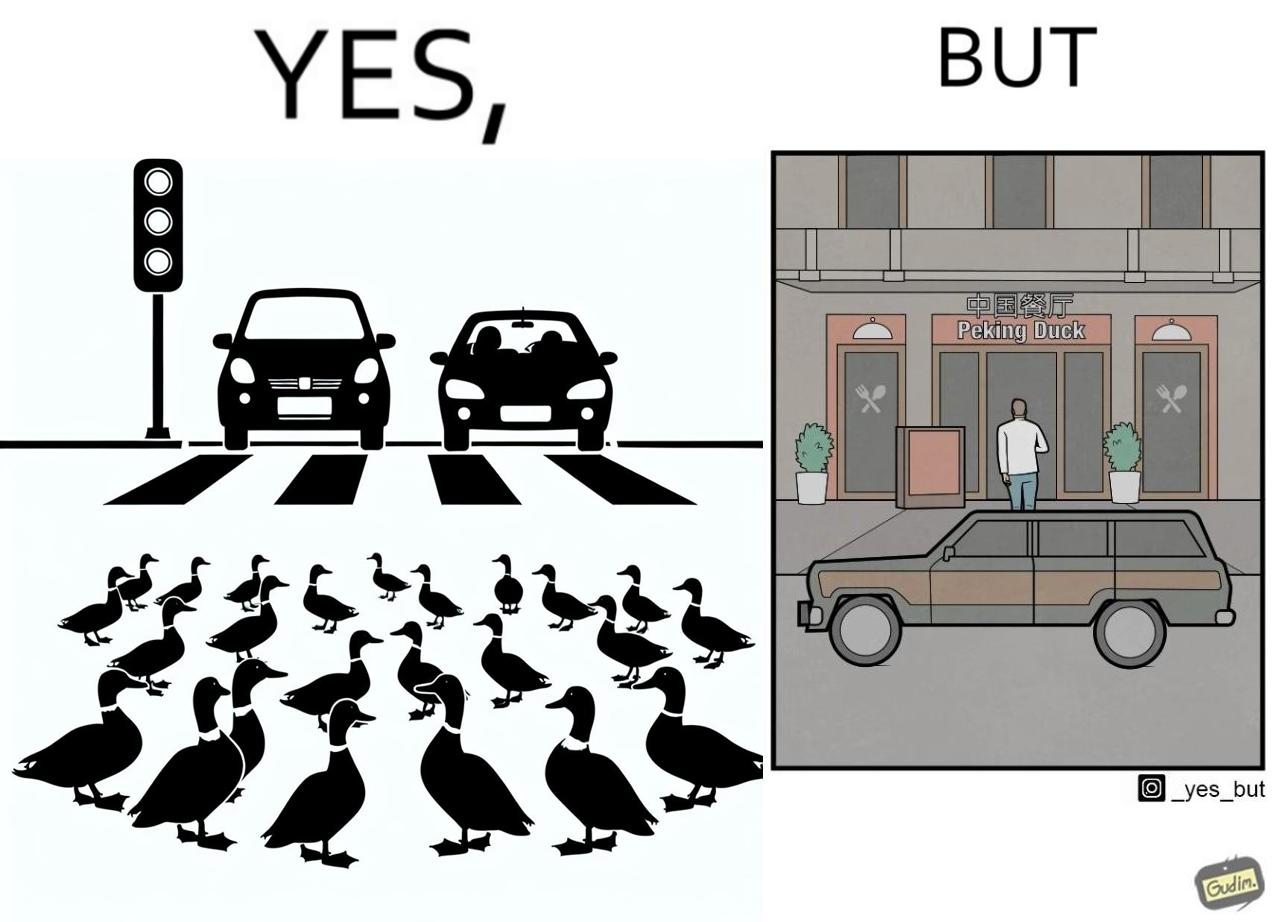Explain the humor or irony in this image. The images are ironic since they show how a man supposedly cares for ducks since he stops his vehicle to give way to queue of ducks allowing them to safely cross a road but on the other hand he goes to a peking duck shop to buy and eat similar ducks after having them killed 